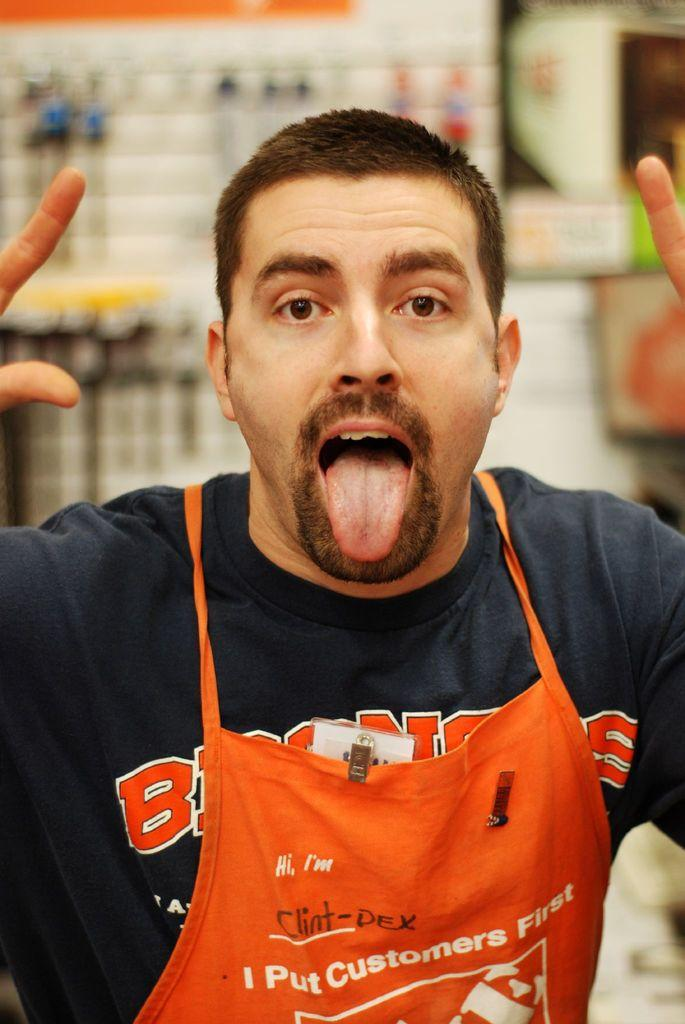<image>
Provide a brief description of the given image. Man wearing an orange apron which says "I put customers first". 